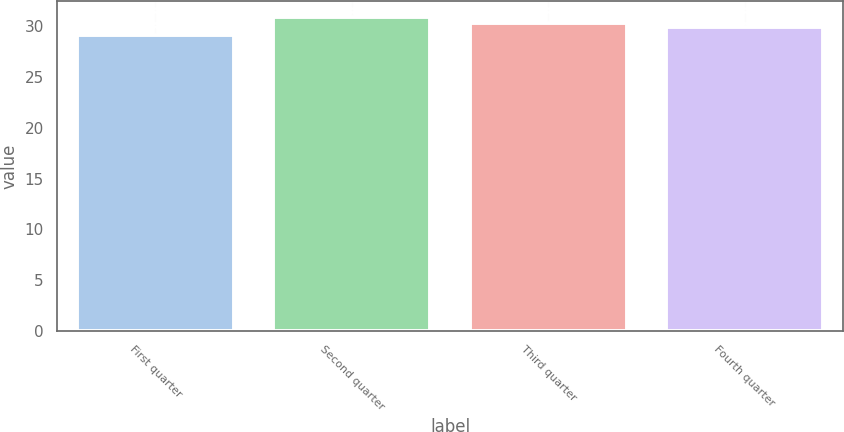Convert chart. <chart><loc_0><loc_0><loc_500><loc_500><bar_chart><fcel>First quarter<fcel>Second quarter<fcel>Third quarter<fcel>Fourth quarter<nl><fcel>29.1<fcel>30.96<fcel>30.29<fcel>29.95<nl></chart> 